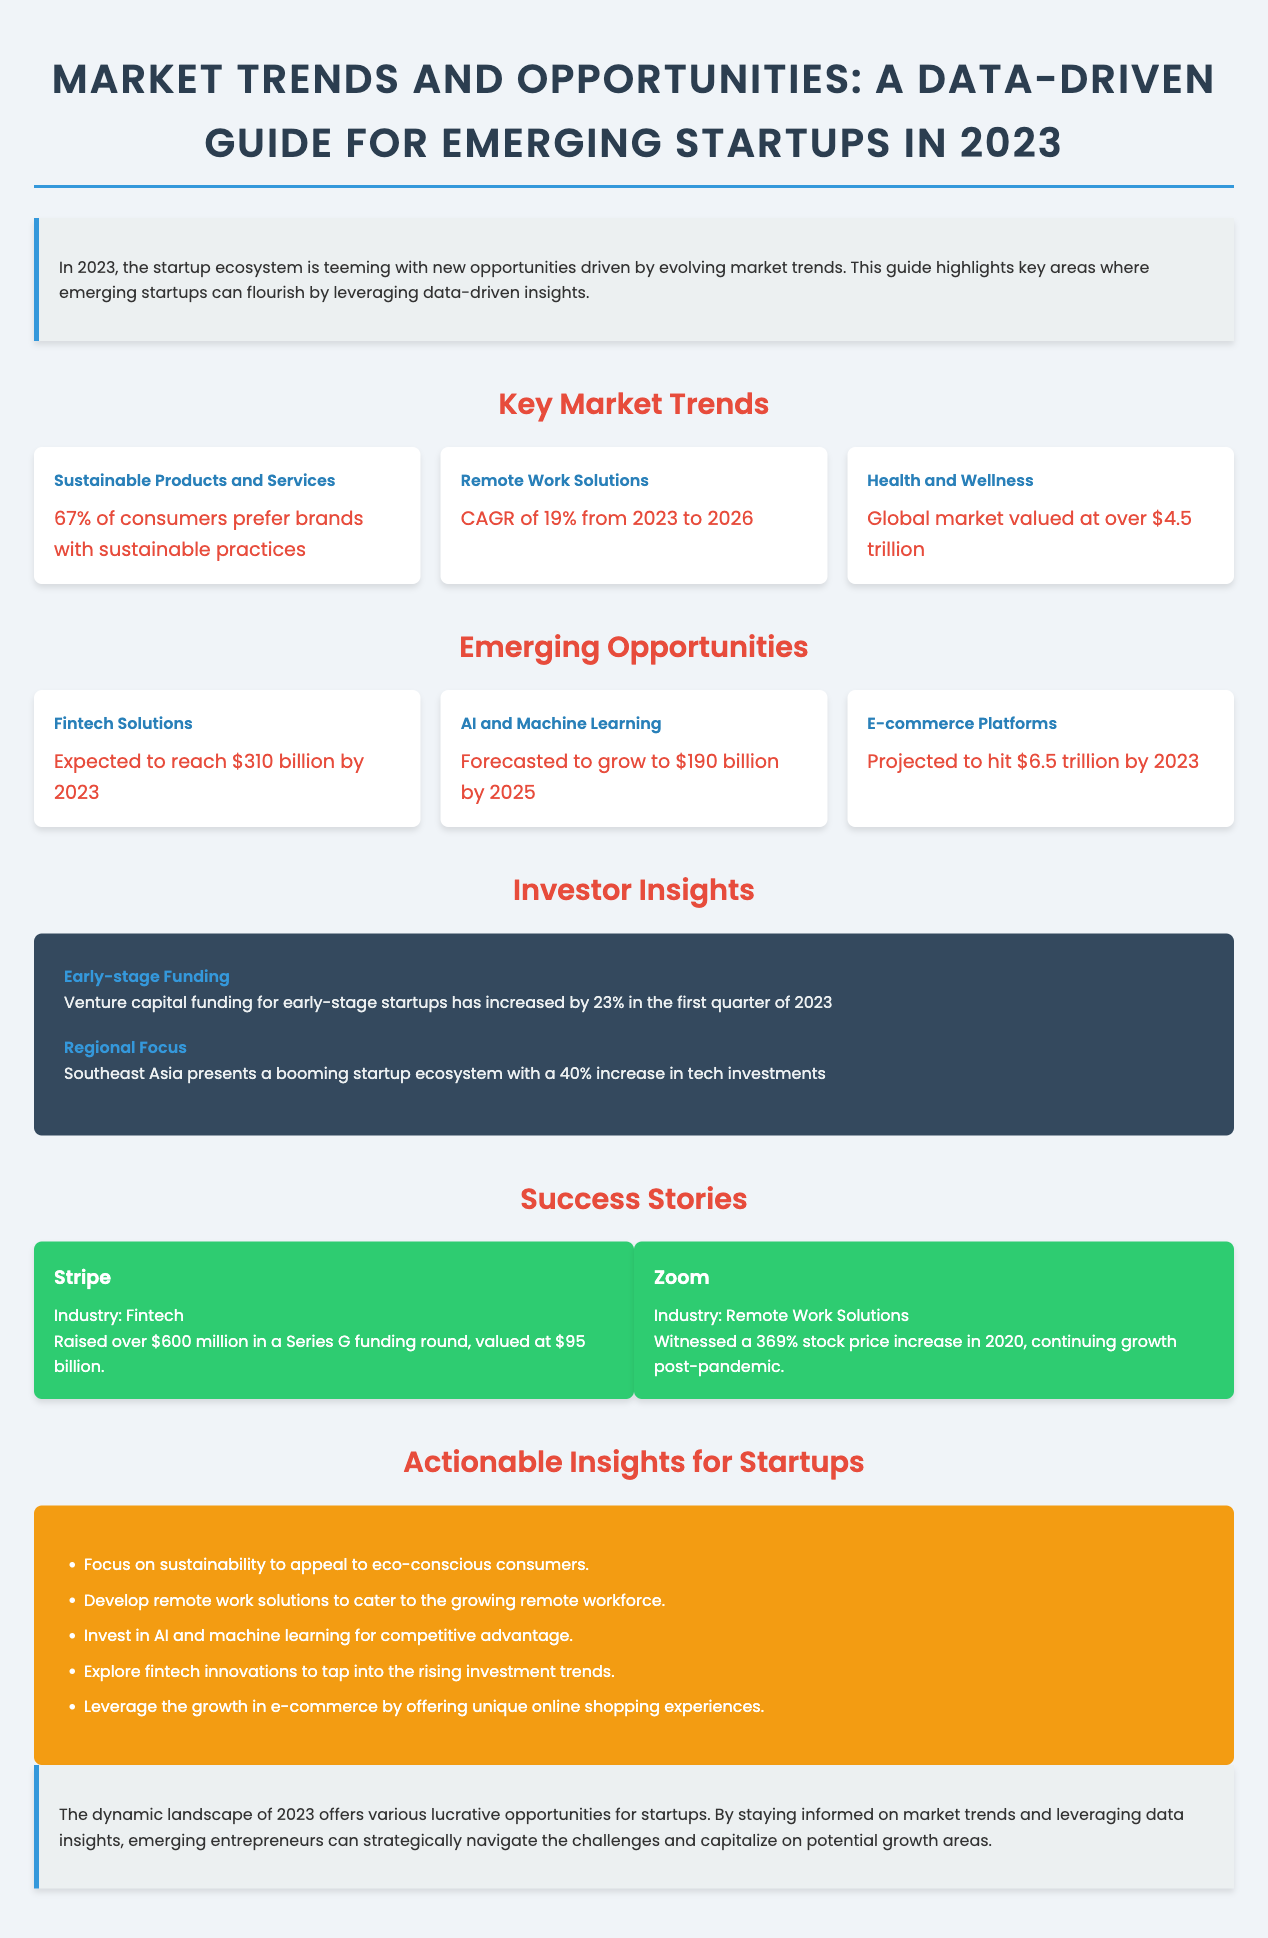What percentage of consumers prefer brands with sustainable practices? The statistic states that 67% of consumers prefer brands with sustainable practices.
Answer: 67% What is the projected CAGR for remote work solutions from 2023 to 2026? The document mentions a CAGR of 19% for remote work solutions during this period.
Answer: 19% What is the global market valuation for health and wellness? The document indicates that the global market for health and wellness is valued at over $4.5 trillion.
Answer: Over $4.5 trillion How much is expected to be raised in fintech solutions by 2023? The expected revenue for fintech solutions is specified as $310 billion by 2023.
Answer: $310 billion Which region shows a 40% increase in tech investments? The document states that Southeast Asia is the region presenting a 40% increase in tech investments.
Answer: Southeast Asia What was the stock price increase percentage for Zoom in 2020? The document details that Zoom witnessed a 369% stock price increase in 2020.
Answer: 369% What should startups focus on to appeal to eco-conscious consumers? Startups are encouraged to focus on sustainability to achieve this goal.
Answer: Sustainability Which industry did Stripe operate in according to the success stories? The document categorizes Stripe under the fintech industry.
Answer: Fintech What is the projected revenue for e-commerce platforms by 2023? The document projects that e-commerce platforms will hit $6.5 trillion by 2023.
Answer: $6.5 trillion 